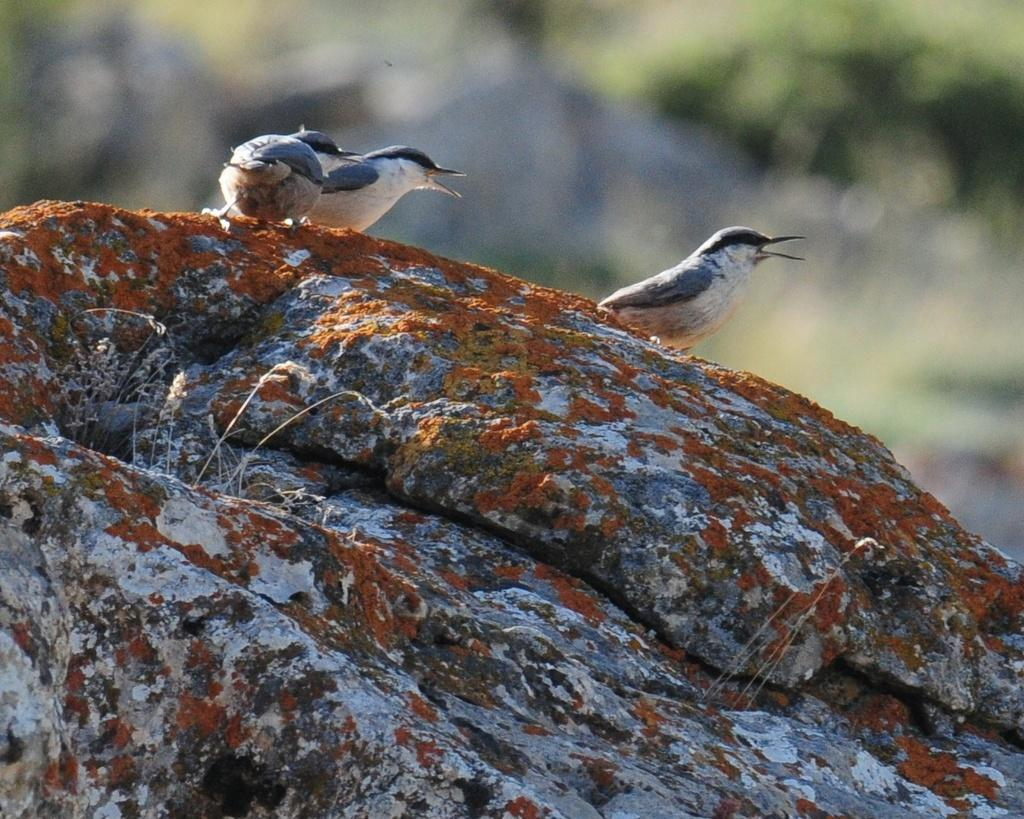What is the main focus of the image? The main focus of the image is the birds on a rock. How is the background of the image depicted? The background portion of the picture is blurred. Are there any plants visible in the image? Yes, tiny plants are visible in the image. What type of comb is being used by the lizards in the image? There are no lizards present in the image, so there is no comb being used. What topic are the birds discussing on the rock in the image? Birds do not engage in discussions, and there is no indication of any conversation in the image. 